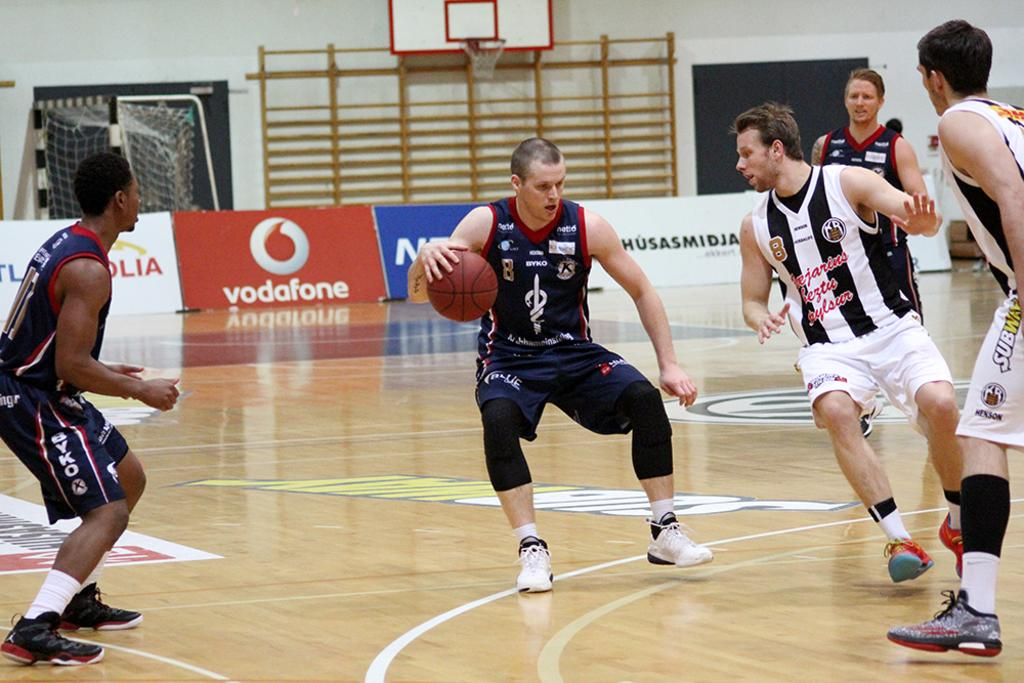Provide a one-sentence caption for the provided image. Men are playing basketball and on the sidelines there is an ad for vodaphone. 